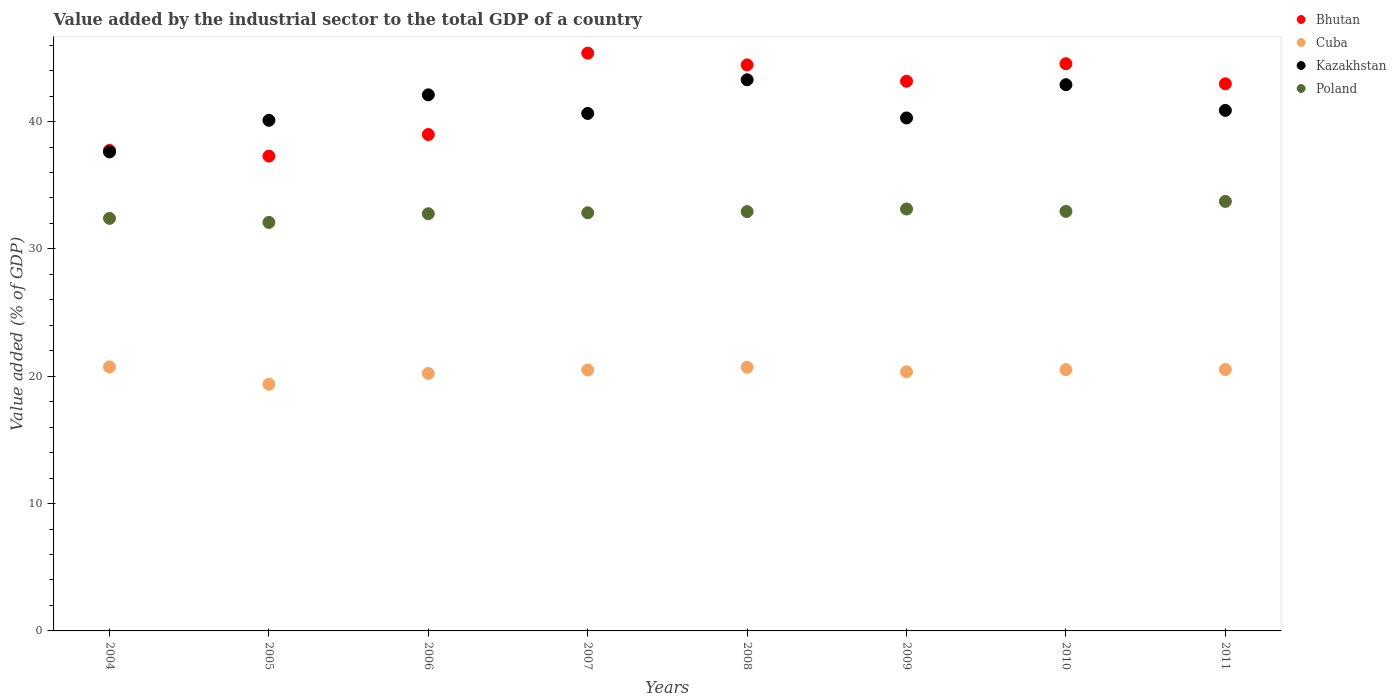What is the value added by the industrial sector to the total GDP in Cuba in 2006?
Make the answer very short. 20.22. Across all years, what is the maximum value added by the industrial sector to the total GDP in Bhutan?
Your answer should be compact. 45.38. Across all years, what is the minimum value added by the industrial sector to the total GDP in Kazakhstan?
Your response must be concise. 37.62. In which year was the value added by the industrial sector to the total GDP in Poland maximum?
Provide a short and direct response. 2011. In which year was the value added by the industrial sector to the total GDP in Cuba minimum?
Keep it short and to the point. 2005. What is the total value added by the industrial sector to the total GDP in Bhutan in the graph?
Ensure brevity in your answer.  334.52. What is the difference between the value added by the industrial sector to the total GDP in Cuba in 2006 and that in 2008?
Your answer should be compact. -0.49. What is the difference between the value added by the industrial sector to the total GDP in Cuba in 2005 and the value added by the industrial sector to the total GDP in Bhutan in 2009?
Make the answer very short. -23.8. What is the average value added by the industrial sector to the total GDP in Cuba per year?
Your response must be concise. 20.37. In the year 2010, what is the difference between the value added by the industrial sector to the total GDP in Poland and value added by the industrial sector to the total GDP in Bhutan?
Ensure brevity in your answer.  -11.6. In how many years, is the value added by the industrial sector to the total GDP in Cuba greater than 10 %?
Your response must be concise. 8. What is the ratio of the value added by the industrial sector to the total GDP in Bhutan in 2004 to that in 2007?
Your response must be concise. 0.83. Is the value added by the industrial sector to the total GDP in Poland in 2007 less than that in 2009?
Provide a succinct answer. Yes. Is the difference between the value added by the industrial sector to the total GDP in Poland in 2004 and 2007 greater than the difference between the value added by the industrial sector to the total GDP in Bhutan in 2004 and 2007?
Your response must be concise. Yes. What is the difference between the highest and the second highest value added by the industrial sector to the total GDP in Cuba?
Provide a short and direct response. 0.03. What is the difference between the highest and the lowest value added by the industrial sector to the total GDP in Bhutan?
Ensure brevity in your answer.  8.09. In how many years, is the value added by the industrial sector to the total GDP in Cuba greater than the average value added by the industrial sector to the total GDP in Cuba taken over all years?
Give a very brief answer. 5. Is the value added by the industrial sector to the total GDP in Bhutan strictly greater than the value added by the industrial sector to the total GDP in Poland over the years?
Give a very brief answer. Yes. Is the value added by the industrial sector to the total GDP in Bhutan strictly less than the value added by the industrial sector to the total GDP in Cuba over the years?
Give a very brief answer. No. Does the graph contain grids?
Offer a very short reply. No. How are the legend labels stacked?
Keep it short and to the point. Vertical. What is the title of the graph?
Give a very brief answer. Value added by the industrial sector to the total GDP of a country. Does "New Zealand" appear as one of the legend labels in the graph?
Provide a short and direct response. No. What is the label or title of the Y-axis?
Your response must be concise. Value added (% of GDP). What is the Value added (% of GDP) in Bhutan in 2004?
Make the answer very short. 37.74. What is the Value added (% of GDP) of Cuba in 2004?
Ensure brevity in your answer.  20.74. What is the Value added (% of GDP) in Kazakhstan in 2004?
Make the answer very short. 37.62. What is the Value added (% of GDP) of Poland in 2004?
Your answer should be very brief. 32.4. What is the Value added (% of GDP) of Bhutan in 2005?
Provide a short and direct response. 37.29. What is the Value added (% of GDP) of Cuba in 2005?
Provide a succinct answer. 19.37. What is the Value added (% of GDP) of Kazakhstan in 2005?
Make the answer very short. 40.1. What is the Value added (% of GDP) of Poland in 2005?
Keep it short and to the point. 32.08. What is the Value added (% of GDP) in Bhutan in 2006?
Keep it short and to the point. 38.99. What is the Value added (% of GDP) in Cuba in 2006?
Your answer should be compact. 20.22. What is the Value added (% of GDP) in Kazakhstan in 2006?
Make the answer very short. 42.1. What is the Value added (% of GDP) in Poland in 2006?
Make the answer very short. 32.76. What is the Value added (% of GDP) of Bhutan in 2007?
Make the answer very short. 45.38. What is the Value added (% of GDP) of Cuba in 2007?
Ensure brevity in your answer.  20.49. What is the Value added (% of GDP) of Kazakhstan in 2007?
Your response must be concise. 40.64. What is the Value added (% of GDP) of Poland in 2007?
Your answer should be compact. 32.84. What is the Value added (% of GDP) in Bhutan in 2008?
Keep it short and to the point. 44.45. What is the Value added (% of GDP) of Cuba in 2008?
Provide a short and direct response. 20.71. What is the Value added (% of GDP) in Kazakhstan in 2008?
Ensure brevity in your answer.  43.28. What is the Value added (% of GDP) of Poland in 2008?
Make the answer very short. 32.93. What is the Value added (% of GDP) of Bhutan in 2009?
Make the answer very short. 43.17. What is the Value added (% of GDP) in Cuba in 2009?
Offer a very short reply. 20.35. What is the Value added (% of GDP) in Kazakhstan in 2009?
Your response must be concise. 40.28. What is the Value added (% of GDP) in Poland in 2009?
Make the answer very short. 33.13. What is the Value added (% of GDP) of Bhutan in 2010?
Ensure brevity in your answer.  44.55. What is the Value added (% of GDP) of Cuba in 2010?
Provide a short and direct response. 20.52. What is the Value added (% of GDP) in Kazakhstan in 2010?
Offer a terse response. 42.9. What is the Value added (% of GDP) in Poland in 2010?
Your answer should be compact. 32.95. What is the Value added (% of GDP) of Bhutan in 2011?
Provide a short and direct response. 42.97. What is the Value added (% of GDP) of Cuba in 2011?
Provide a succinct answer. 20.53. What is the Value added (% of GDP) of Kazakhstan in 2011?
Your answer should be compact. 40.88. What is the Value added (% of GDP) of Poland in 2011?
Offer a terse response. 33.73. Across all years, what is the maximum Value added (% of GDP) in Bhutan?
Make the answer very short. 45.38. Across all years, what is the maximum Value added (% of GDP) of Cuba?
Offer a terse response. 20.74. Across all years, what is the maximum Value added (% of GDP) of Kazakhstan?
Offer a terse response. 43.28. Across all years, what is the maximum Value added (% of GDP) in Poland?
Ensure brevity in your answer.  33.73. Across all years, what is the minimum Value added (% of GDP) in Bhutan?
Give a very brief answer. 37.29. Across all years, what is the minimum Value added (% of GDP) in Cuba?
Provide a succinct answer. 19.37. Across all years, what is the minimum Value added (% of GDP) of Kazakhstan?
Provide a short and direct response. 37.62. Across all years, what is the minimum Value added (% of GDP) of Poland?
Your answer should be very brief. 32.08. What is the total Value added (% of GDP) in Bhutan in the graph?
Ensure brevity in your answer.  334.52. What is the total Value added (% of GDP) in Cuba in the graph?
Offer a very short reply. 162.92. What is the total Value added (% of GDP) in Kazakhstan in the graph?
Your response must be concise. 327.8. What is the total Value added (% of GDP) in Poland in the graph?
Give a very brief answer. 262.82. What is the difference between the Value added (% of GDP) of Bhutan in 2004 and that in 2005?
Your answer should be compact. 0.45. What is the difference between the Value added (% of GDP) in Cuba in 2004 and that in 2005?
Make the answer very short. 1.36. What is the difference between the Value added (% of GDP) of Kazakhstan in 2004 and that in 2005?
Keep it short and to the point. -2.48. What is the difference between the Value added (% of GDP) in Poland in 2004 and that in 2005?
Keep it short and to the point. 0.32. What is the difference between the Value added (% of GDP) of Bhutan in 2004 and that in 2006?
Your answer should be compact. -1.24. What is the difference between the Value added (% of GDP) in Cuba in 2004 and that in 2006?
Provide a succinct answer. 0.51. What is the difference between the Value added (% of GDP) of Kazakhstan in 2004 and that in 2006?
Make the answer very short. -4.49. What is the difference between the Value added (% of GDP) in Poland in 2004 and that in 2006?
Your answer should be compact. -0.36. What is the difference between the Value added (% of GDP) of Bhutan in 2004 and that in 2007?
Offer a very short reply. -7.63. What is the difference between the Value added (% of GDP) of Cuba in 2004 and that in 2007?
Keep it short and to the point. 0.24. What is the difference between the Value added (% of GDP) in Kazakhstan in 2004 and that in 2007?
Provide a short and direct response. -3.02. What is the difference between the Value added (% of GDP) of Poland in 2004 and that in 2007?
Offer a terse response. -0.44. What is the difference between the Value added (% of GDP) of Bhutan in 2004 and that in 2008?
Provide a short and direct response. -6.71. What is the difference between the Value added (% of GDP) of Cuba in 2004 and that in 2008?
Your answer should be very brief. 0.03. What is the difference between the Value added (% of GDP) in Kazakhstan in 2004 and that in 2008?
Your answer should be compact. -5.67. What is the difference between the Value added (% of GDP) in Poland in 2004 and that in 2008?
Give a very brief answer. -0.53. What is the difference between the Value added (% of GDP) of Bhutan in 2004 and that in 2009?
Offer a terse response. -5.43. What is the difference between the Value added (% of GDP) of Cuba in 2004 and that in 2009?
Ensure brevity in your answer.  0.38. What is the difference between the Value added (% of GDP) in Kazakhstan in 2004 and that in 2009?
Your response must be concise. -2.67. What is the difference between the Value added (% of GDP) of Poland in 2004 and that in 2009?
Provide a short and direct response. -0.74. What is the difference between the Value added (% of GDP) in Bhutan in 2004 and that in 2010?
Keep it short and to the point. -6.8. What is the difference between the Value added (% of GDP) of Cuba in 2004 and that in 2010?
Offer a very short reply. 0.22. What is the difference between the Value added (% of GDP) in Kazakhstan in 2004 and that in 2010?
Offer a very short reply. -5.28. What is the difference between the Value added (% of GDP) in Poland in 2004 and that in 2010?
Offer a very short reply. -0.55. What is the difference between the Value added (% of GDP) in Bhutan in 2004 and that in 2011?
Offer a very short reply. -5.22. What is the difference between the Value added (% of GDP) in Cuba in 2004 and that in 2011?
Keep it short and to the point. 0.21. What is the difference between the Value added (% of GDP) in Kazakhstan in 2004 and that in 2011?
Make the answer very short. -3.26. What is the difference between the Value added (% of GDP) in Poland in 2004 and that in 2011?
Offer a terse response. -1.33. What is the difference between the Value added (% of GDP) in Bhutan in 2005 and that in 2006?
Offer a terse response. -1.7. What is the difference between the Value added (% of GDP) in Cuba in 2005 and that in 2006?
Ensure brevity in your answer.  -0.85. What is the difference between the Value added (% of GDP) of Kazakhstan in 2005 and that in 2006?
Ensure brevity in your answer.  -2. What is the difference between the Value added (% of GDP) of Poland in 2005 and that in 2006?
Offer a terse response. -0.68. What is the difference between the Value added (% of GDP) of Bhutan in 2005 and that in 2007?
Your response must be concise. -8.09. What is the difference between the Value added (% of GDP) of Cuba in 2005 and that in 2007?
Your response must be concise. -1.12. What is the difference between the Value added (% of GDP) of Kazakhstan in 2005 and that in 2007?
Your response must be concise. -0.54. What is the difference between the Value added (% of GDP) in Poland in 2005 and that in 2007?
Ensure brevity in your answer.  -0.76. What is the difference between the Value added (% of GDP) of Bhutan in 2005 and that in 2008?
Give a very brief answer. -7.16. What is the difference between the Value added (% of GDP) of Cuba in 2005 and that in 2008?
Give a very brief answer. -1.34. What is the difference between the Value added (% of GDP) of Kazakhstan in 2005 and that in 2008?
Provide a succinct answer. -3.18. What is the difference between the Value added (% of GDP) in Poland in 2005 and that in 2008?
Offer a terse response. -0.85. What is the difference between the Value added (% of GDP) of Bhutan in 2005 and that in 2009?
Make the answer very short. -5.88. What is the difference between the Value added (% of GDP) in Cuba in 2005 and that in 2009?
Keep it short and to the point. -0.98. What is the difference between the Value added (% of GDP) of Kazakhstan in 2005 and that in 2009?
Give a very brief answer. -0.18. What is the difference between the Value added (% of GDP) of Poland in 2005 and that in 2009?
Give a very brief answer. -1.05. What is the difference between the Value added (% of GDP) of Bhutan in 2005 and that in 2010?
Give a very brief answer. -7.26. What is the difference between the Value added (% of GDP) in Cuba in 2005 and that in 2010?
Ensure brevity in your answer.  -1.15. What is the difference between the Value added (% of GDP) of Kazakhstan in 2005 and that in 2010?
Provide a succinct answer. -2.8. What is the difference between the Value added (% of GDP) in Poland in 2005 and that in 2010?
Keep it short and to the point. -0.87. What is the difference between the Value added (% of GDP) of Bhutan in 2005 and that in 2011?
Offer a terse response. -5.68. What is the difference between the Value added (% of GDP) of Cuba in 2005 and that in 2011?
Keep it short and to the point. -1.16. What is the difference between the Value added (% of GDP) in Kazakhstan in 2005 and that in 2011?
Provide a succinct answer. -0.78. What is the difference between the Value added (% of GDP) in Poland in 2005 and that in 2011?
Provide a short and direct response. -1.65. What is the difference between the Value added (% of GDP) in Bhutan in 2006 and that in 2007?
Provide a short and direct response. -6.39. What is the difference between the Value added (% of GDP) of Cuba in 2006 and that in 2007?
Your answer should be very brief. -0.27. What is the difference between the Value added (% of GDP) in Kazakhstan in 2006 and that in 2007?
Offer a terse response. 1.46. What is the difference between the Value added (% of GDP) in Poland in 2006 and that in 2007?
Make the answer very short. -0.07. What is the difference between the Value added (% of GDP) of Bhutan in 2006 and that in 2008?
Your answer should be very brief. -5.47. What is the difference between the Value added (% of GDP) in Cuba in 2006 and that in 2008?
Give a very brief answer. -0.49. What is the difference between the Value added (% of GDP) of Kazakhstan in 2006 and that in 2008?
Keep it short and to the point. -1.18. What is the difference between the Value added (% of GDP) in Poland in 2006 and that in 2008?
Your response must be concise. -0.16. What is the difference between the Value added (% of GDP) of Bhutan in 2006 and that in 2009?
Your answer should be very brief. -4.18. What is the difference between the Value added (% of GDP) in Cuba in 2006 and that in 2009?
Offer a very short reply. -0.13. What is the difference between the Value added (% of GDP) of Kazakhstan in 2006 and that in 2009?
Make the answer very short. 1.82. What is the difference between the Value added (% of GDP) of Poland in 2006 and that in 2009?
Provide a short and direct response. -0.37. What is the difference between the Value added (% of GDP) of Bhutan in 2006 and that in 2010?
Ensure brevity in your answer.  -5.56. What is the difference between the Value added (% of GDP) in Cuba in 2006 and that in 2010?
Offer a very short reply. -0.3. What is the difference between the Value added (% of GDP) in Kazakhstan in 2006 and that in 2010?
Your answer should be compact. -0.8. What is the difference between the Value added (% of GDP) in Poland in 2006 and that in 2010?
Provide a succinct answer. -0.18. What is the difference between the Value added (% of GDP) in Bhutan in 2006 and that in 2011?
Make the answer very short. -3.98. What is the difference between the Value added (% of GDP) of Cuba in 2006 and that in 2011?
Provide a short and direct response. -0.3. What is the difference between the Value added (% of GDP) of Kazakhstan in 2006 and that in 2011?
Provide a short and direct response. 1.22. What is the difference between the Value added (% of GDP) in Poland in 2006 and that in 2011?
Your response must be concise. -0.97. What is the difference between the Value added (% of GDP) of Bhutan in 2007 and that in 2008?
Make the answer very short. 0.92. What is the difference between the Value added (% of GDP) in Cuba in 2007 and that in 2008?
Provide a short and direct response. -0.21. What is the difference between the Value added (% of GDP) of Kazakhstan in 2007 and that in 2008?
Your response must be concise. -2.65. What is the difference between the Value added (% of GDP) in Poland in 2007 and that in 2008?
Ensure brevity in your answer.  -0.09. What is the difference between the Value added (% of GDP) in Bhutan in 2007 and that in 2009?
Offer a terse response. 2.21. What is the difference between the Value added (% of GDP) of Cuba in 2007 and that in 2009?
Ensure brevity in your answer.  0.14. What is the difference between the Value added (% of GDP) in Kazakhstan in 2007 and that in 2009?
Keep it short and to the point. 0.35. What is the difference between the Value added (% of GDP) in Poland in 2007 and that in 2009?
Give a very brief answer. -0.3. What is the difference between the Value added (% of GDP) in Bhutan in 2007 and that in 2010?
Make the answer very short. 0.83. What is the difference between the Value added (% of GDP) in Cuba in 2007 and that in 2010?
Offer a very short reply. -0.02. What is the difference between the Value added (% of GDP) in Kazakhstan in 2007 and that in 2010?
Make the answer very short. -2.26. What is the difference between the Value added (% of GDP) of Poland in 2007 and that in 2010?
Your response must be concise. -0.11. What is the difference between the Value added (% of GDP) in Bhutan in 2007 and that in 2011?
Offer a very short reply. 2.41. What is the difference between the Value added (% of GDP) in Cuba in 2007 and that in 2011?
Offer a very short reply. -0.03. What is the difference between the Value added (% of GDP) of Kazakhstan in 2007 and that in 2011?
Offer a very short reply. -0.24. What is the difference between the Value added (% of GDP) of Poland in 2007 and that in 2011?
Your answer should be compact. -0.89. What is the difference between the Value added (% of GDP) in Bhutan in 2008 and that in 2009?
Offer a very short reply. 1.28. What is the difference between the Value added (% of GDP) of Cuba in 2008 and that in 2009?
Your answer should be compact. 0.35. What is the difference between the Value added (% of GDP) of Kazakhstan in 2008 and that in 2009?
Your answer should be compact. 3. What is the difference between the Value added (% of GDP) in Poland in 2008 and that in 2009?
Give a very brief answer. -0.21. What is the difference between the Value added (% of GDP) in Bhutan in 2008 and that in 2010?
Offer a terse response. -0.09. What is the difference between the Value added (% of GDP) in Cuba in 2008 and that in 2010?
Your response must be concise. 0.19. What is the difference between the Value added (% of GDP) of Kazakhstan in 2008 and that in 2010?
Offer a terse response. 0.39. What is the difference between the Value added (% of GDP) of Poland in 2008 and that in 2010?
Your response must be concise. -0.02. What is the difference between the Value added (% of GDP) of Bhutan in 2008 and that in 2011?
Your answer should be compact. 1.48. What is the difference between the Value added (% of GDP) in Cuba in 2008 and that in 2011?
Make the answer very short. 0.18. What is the difference between the Value added (% of GDP) of Kazakhstan in 2008 and that in 2011?
Make the answer very short. 2.4. What is the difference between the Value added (% of GDP) in Poland in 2008 and that in 2011?
Give a very brief answer. -0.8. What is the difference between the Value added (% of GDP) of Bhutan in 2009 and that in 2010?
Ensure brevity in your answer.  -1.38. What is the difference between the Value added (% of GDP) of Cuba in 2009 and that in 2010?
Ensure brevity in your answer.  -0.16. What is the difference between the Value added (% of GDP) of Kazakhstan in 2009 and that in 2010?
Offer a terse response. -2.61. What is the difference between the Value added (% of GDP) in Poland in 2009 and that in 2010?
Provide a succinct answer. 0.19. What is the difference between the Value added (% of GDP) in Bhutan in 2009 and that in 2011?
Make the answer very short. 0.2. What is the difference between the Value added (% of GDP) in Cuba in 2009 and that in 2011?
Provide a short and direct response. -0.17. What is the difference between the Value added (% of GDP) in Kazakhstan in 2009 and that in 2011?
Keep it short and to the point. -0.59. What is the difference between the Value added (% of GDP) in Poland in 2009 and that in 2011?
Your response must be concise. -0.6. What is the difference between the Value added (% of GDP) of Bhutan in 2010 and that in 2011?
Make the answer very short. 1.58. What is the difference between the Value added (% of GDP) in Cuba in 2010 and that in 2011?
Make the answer very short. -0.01. What is the difference between the Value added (% of GDP) of Kazakhstan in 2010 and that in 2011?
Your answer should be very brief. 2.02. What is the difference between the Value added (% of GDP) in Poland in 2010 and that in 2011?
Offer a terse response. -0.78. What is the difference between the Value added (% of GDP) of Bhutan in 2004 and the Value added (% of GDP) of Cuba in 2005?
Provide a succinct answer. 18.37. What is the difference between the Value added (% of GDP) in Bhutan in 2004 and the Value added (% of GDP) in Kazakhstan in 2005?
Keep it short and to the point. -2.36. What is the difference between the Value added (% of GDP) in Bhutan in 2004 and the Value added (% of GDP) in Poland in 2005?
Your response must be concise. 5.66. What is the difference between the Value added (% of GDP) in Cuba in 2004 and the Value added (% of GDP) in Kazakhstan in 2005?
Your answer should be compact. -19.36. What is the difference between the Value added (% of GDP) in Cuba in 2004 and the Value added (% of GDP) in Poland in 2005?
Your response must be concise. -11.35. What is the difference between the Value added (% of GDP) in Kazakhstan in 2004 and the Value added (% of GDP) in Poland in 2005?
Ensure brevity in your answer.  5.53. What is the difference between the Value added (% of GDP) in Bhutan in 2004 and the Value added (% of GDP) in Cuba in 2006?
Give a very brief answer. 17.52. What is the difference between the Value added (% of GDP) in Bhutan in 2004 and the Value added (% of GDP) in Kazakhstan in 2006?
Provide a short and direct response. -4.36. What is the difference between the Value added (% of GDP) in Bhutan in 2004 and the Value added (% of GDP) in Poland in 2006?
Provide a short and direct response. 4.98. What is the difference between the Value added (% of GDP) in Cuba in 2004 and the Value added (% of GDP) in Kazakhstan in 2006?
Give a very brief answer. -21.37. What is the difference between the Value added (% of GDP) of Cuba in 2004 and the Value added (% of GDP) of Poland in 2006?
Provide a short and direct response. -12.03. What is the difference between the Value added (% of GDP) in Kazakhstan in 2004 and the Value added (% of GDP) in Poland in 2006?
Your answer should be compact. 4.85. What is the difference between the Value added (% of GDP) of Bhutan in 2004 and the Value added (% of GDP) of Cuba in 2007?
Offer a terse response. 17.25. What is the difference between the Value added (% of GDP) of Bhutan in 2004 and the Value added (% of GDP) of Kazakhstan in 2007?
Your answer should be compact. -2.9. What is the difference between the Value added (% of GDP) in Bhutan in 2004 and the Value added (% of GDP) in Poland in 2007?
Your answer should be very brief. 4.9. What is the difference between the Value added (% of GDP) in Cuba in 2004 and the Value added (% of GDP) in Kazakhstan in 2007?
Provide a short and direct response. -19.9. What is the difference between the Value added (% of GDP) in Cuba in 2004 and the Value added (% of GDP) in Poland in 2007?
Offer a very short reply. -12.1. What is the difference between the Value added (% of GDP) of Kazakhstan in 2004 and the Value added (% of GDP) of Poland in 2007?
Ensure brevity in your answer.  4.78. What is the difference between the Value added (% of GDP) in Bhutan in 2004 and the Value added (% of GDP) in Cuba in 2008?
Your answer should be very brief. 17.04. What is the difference between the Value added (% of GDP) of Bhutan in 2004 and the Value added (% of GDP) of Kazakhstan in 2008?
Offer a very short reply. -5.54. What is the difference between the Value added (% of GDP) in Bhutan in 2004 and the Value added (% of GDP) in Poland in 2008?
Offer a terse response. 4.81. What is the difference between the Value added (% of GDP) in Cuba in 2004 and the Value added (% of GDP) in Kazakhstan in 2008?
Make the answer very short. -22.55. What is the difference between the Value added (% of GDP) of Cuba in 2004 and the Value added (% of GDP) of Poland in 2008?
Offer a terse response. -12.19. What is the difference between the Value added (% of GDP) of Kazakhstan in 2004 and the Value added (% of GDP) of Poland in 2008?
Keep it short and to the point. 4.69. What is the difference between the Value added (% of GDP) in Bhutan in 2004 and the Value added (% of GDP) in Cuba in 2009?
Make the answer very short. 17.39. What is the difference between the Value added (% of GDP) of Bhutan in 2004 and the Value added (% of GDP) of Kazakhstan in 2009?
Keep it short and to the point. -2.54. What is the difference between the Value added (% of GDP) in Bhutan in 2004 and the Value added (% of GDP) in Poland in 2009?
Give a very brief answer. 4.61. What is the difference between the Value added (% of GDP) in Cuba in 2004 and the Value added (% of GDP) in Kazakhstan in 2009?
Ensure brevity in your answer.  -19.55. What is the difference between the Value added (% of GDP) in Cuba in 2004 and the Value added (% of GDP) in Poland in 2009?
Make the answer very short. -12.4. What is the difference between the Value added (% of GDP) in Kazakhstan in 2004 and the Value added (% of GDP) in Poland in 2009?
Your response must be concise. 4.48. What is the difference between the Value added (% of GDP) in Bhutan in 2004 and the Value added (% of GDP) in Cuba in 2010?
Make the answer very short. 17.23. What is the difference between the Value added (% of GDP) in Bhutan in 2004 and the Value added (% of GDP) in Kazakhstan in 2010?
Offer a terse response. -5.15. What is the difference between the Value added (% of GDP) in Bhutan in 2004 and the Value added (% of GDP) in Poland in 2010?
Your answer should be very brief. 4.8. What is the difference between the Value added (% of GDP) in Cuba in 2004 and the Value added (% of GDP) in Kazakhstan in 2010?
Give a very brief answer. -22.16. What is the difference between the Value added (% of GDP) of Cuba in 2004 and the Value added (% of GDP) of Poland in 2010?
Offer a terse response. -12.21. What is the difference between the Value added (% of GDP) of Kazakhstan in 2004 and the Value added (% of GDP) of Poland in 2010?
Offer a terse response. 4.67. What is the difference between the Value added (% of GDP) in Bhutan in 2004 and the Value added (% of GDP) in Cuba in 2011?
Give a very brief answer. 17.22. What is the difference between the Value added (% of GDP) of Bhutan in 2004 and the Value added (% of GDP) of Kazakhstan in 2011?
Make the answer very short. -3.14. What is the difference between the Value added (% of GDP) in Bhutan in 2004 and the Value added (% of GDP) in Poland in 2011?
Keep it short and to the point. 4.01. What is the difference between the Value added (% of GDP) of Cuba in 2004 and the Value added (% of GDP) of Kazakhstan in 2011?
Make the answer very short. -20.14. What is the difference between the Value added (% of GDP) in Cuba in 2004 and the Value added (% of GDP) in Poland in 2011?
Offer a terse response. -13. What is the difference between the Value added (% of GDP) in Kazakhstan in 2004 and the Value added (% of GDP) in Poland in 2011?
Ensure brevity in your answer.  3.88. What is the difference between the Value added (% of GDP) of Bhutan in 2005 and the Value added (% of GDP) of Cuba in 2006?
Provide a short and direct response. 17.07. What is the difference between the Value added (% of GDP) of Bhutan in 2005 and the Value added (% of GDP) of Kazakhstan in 2006?
Keep it short and to the point. -4.81. What is the difference between the Value added (% of GDP) in Bhutan in 2005 and the Value added (% of GDP) in Poland in 2006?
Your response must be concise. 4.53. What is the difference between the Value added (% of GDP) of Cuba in 2005 and the Value added (% of GDP) of Kazakhstan in 2006?
Your answer should be compact. -22.73. What is the difference between the Value added (% of GDP) of Cuba in 2005 and the Value added (% of GDP) of Poland in 2006?
Provide a succinct answer. -13.39. What is the difference between the Value added (% of GDP) in Kazakhstan in 2005 and the Value added (% of GDP) in Poland in 2006?
Your answer should be very brief. 7.34. What is the difference between the Value added (% of GDP) in Bhutan in 2005 and the Value added (% of GDP) in Cuba in 2007?
Make the answer very short. 16.8. What is the difference between the Value added (% of GDP) of Bhutan in 2005 and the Value added (% of GDP) of Kazakhstan in 2007?
Ensure brevity in your answer.  -3.35. What is the difference between the Value added (% of GDP) of Bhutan in 2005 and the Value added (% of GDP) of Poland in 2007?
Provide a short and direct response. 4.45. What is the difference between the Value added (% of GDP) in Cuba in 2005 and the Value added (% of GDP) in Kazakhstan in 2007?
Your answer should be very brief. -21.27. What is the difference between the Value added (% of GDP) in Cuba in 2005 and the Value added (% of GDP) in Poland in 2007?
Your answer should be compact. -13.47. What is the difference between the Value added (% of GDP) in Kazakhstan in 2005 and the Value added (% of GDP) in Poland in 2007?
Your answer should be compact. 7.26. What is the difference between the Value added (% of GDP) in Bhutan in 2005 and the Value added (% of GDP) in Cuba in 2008?
Offer a terse response. 16.58. What is the difference between the Value added (% of GDP) in Bhutan in 2005 and the Value added (% of GDP) in Kazakhstan in 2008?
Your answer should be compact. -6. What is the difference between the Value added (% of GDP) in Bhutan in 2005 and the Value added (% of GDP) in Poland in 2008?
Offer a very short reply. 4.36. What is the difference between the Value added (% of GDP) in Cuba in 2005 and the Value added (% of GDP) in Kazakhstan in 2008?
Your answer should be very brief. -23.91. What is the difference between the Value added (% of GDP) of Cuba in 2005 and the Value added (% of GDP) of Poland in 2008?
Keep it short and to the point. -13.56. What is the difference between the Value added (% of GDP) in Kazakhstan in 2005 and the Value added (% of GDP) in Poland in 2008?
Offer a terse response. 7.17. What is the difference between the Value added (% of GDP) of Bhutan in 2005 and the Value added (% of GDP) of Cuba in 2009?
Your answer should be very brief. 16.94. What is the difference between the Value added (% of GDP) in Bhutan in 2005 and the Value added (% of GDP) in Kazakhstan in 2009?
Provide a succinct answer. -3. What is the difference between the Value added (% of GDP) in Bhutan in 2005 and the Value added (% of GDP) in Poland in 2009?
Give a very brief answer. 4.16. What is the difference between the Value added (% of GDP) of Cuba in 2005 and the Value added (% of GDP) of Kazakhstan in 2009?
Provide a short and direct response. -20.91. What is the difference between the Value added (% of GDP) in Cuba in 2005 and the Value added (% of GDP) in Poland in 2009?
Make the answer very short. -13.76. What is the difference between the Value added (% of GDP) in Kazakhstan in 2005 and the Value added (% of GDP) in Poland in 2009?
Provide a short and direct response. 6.97. What is the difference between the Value added (% of GDP) of Bhutan in 2005 and the Value added (% of GDP) of Cuba in 2010?
Your answer should be compact. 16.77. What is the difference between the Value added (% of GDP) of Bhutan in 2005 and the Value added (% of GDP) of Kazakhstan in 2010?
Offer a terse response. -5.61. What is the difference between the Value added (% of GDP) of Bhutan in 2005 and the Value added (% of GDP) of Poland in 2010?
Keep it short and to the point. 4.34. What is the difference between the Value added (% of GDP) of Cuba in 2005 and the Value added (% of GDP) of Kazakhstan in 2010?
Your answer should be compact. -23.53. What is the difference between the Value added (% of GDP) of Cuba in 2005 and the Value added (% of GDP) of Poland in 2010?
Keep it short and to the point. -13.58. What is the difference between the Value added (% of GDP) in Kazakhstan in 2005 and the Value added (% of GDP) in Poland in 2010?
Give a very brief answer. 7.15. What is the difference between the Value added (% of GDP) in Bhutan in 2005 and the Value added (% of GDP) in Cuba in 2011?
Your answer should be very brief. 16.76. What is the difference between the Value added (% of GDP) of Bhutan in 2005 and the Value added (% of GDP) of Kazakhstan in 2011?
Ensure brevity in your answer.  -3.59. What is the difference between the Value added (% of GDP) of Bhutan in 2005 and the Value added (% of GDP) of Poland in 2011?
Provide a short and direct response. 3.56. What is the difference between the Value added (% of GDP) of Cuba in 2005 and the Value added (% of GDP) of Kazakhstan in 2011?
Give a very brief answer. -21.51. What is the difference between the Value added (% of GDP) of Cuba in 2005 and the Value added (% of GDP) of Poland in 2011?
Offer a very short reply. -14.36. What is the difference between the Value added (% of GDP) in Kazakhstan in 2005 and the Value added (% of GDP) in Poland in 2011?
Keep it short and to the point. 6.37. What is the difference between the Value added (% of GDP) in Bhutan in 2006 and the Value added (% of GDP) in Cuba in 2007?
Your response must be concise. 18.49. What is the difference between the Value added (% of GDP) in Bhutan in 2006 and the Value added (% of GDP) in Kazakhstan in 2007?
Your answer should be compact. -1.65. What is the difference between the Value added (% of GDP) of Bhutan in 2006 and the Value added (% of GDP) of Poland in 2007?
Provide a succinct answer. 6.15. What is the difference between the Value added (% of GDP) of Cuba in 2006 and the Value added (% of GDP) of Kazakhstan in 2007?
Offer a very short reply. -20.42. What is the difference between the Value added (% of GDP) of Cuba in 2006 and the Value added (% of GDP) of Poland in 2007?
Your answer should be compact. -12.62. What is the difference between the Value added (% of GDP) of Kazakhstan in 2006 and the Value added (% of GDP) of Poland in 2007?
Give a very brief answer. 9.26. What is the difference between the Value added (% of GDP) in Bhutan in 2006 and the Value added (% of GDP) in Cuba in 2008?
Offer a terse response. 18.28. What is the difference between the Value added (% of GDP) in Bhutan in 2006 and the Value added (% of GDP) in Kazakhstan in 2008?
Provide a succinct answer. -4.3. What is the difference between the Value added (% of GDP) in Bhutan in 2006 and the Value added (% of GDP) in Poland in 2008?
Keep it short and to the point. 6.06. What is the difference between the Value added (% of GDP) in Cuba in 2006 and the Value added (% of GDP) in Kazakhstan in 2008?
Provide a short and direct response. -23.06. What is the difference between the Value added (% of GDP) in Cuba in 2006 and the Value added (% of GDP) in Poland in 2008?
Your answer should be very brief. -12.71. What is the difference between the Value added (% of GDP) in Kazakhstan in 2006 and the Value added (% of GDP) in Poland in 2008?
Your response must be concise. 9.17. What is the difference between the Value added (% of GDP) of Bhutan in 2006 and the Value added (% of GDP) of Cuba in 2009?
Make the answer very short. 18.63. What is the difference between the Value added (% of GDP) in Bhutan in 2006 and the Value added (% of GDP) in Kazakhstan in 2009?
Make the answer very short. -1.3. What is the difference between the Value added (% of GDP) of Bhutan in 2006 and the Value added (% of GDP) of Poland in 2009?
Ensure brevity in your answer.  5.85. What is the difference between the Value added (% of GDP) in Cuba in 2006 and the Value added (% of GDP) in Kazakhstan in 2009?
Ensure brevity in your answer.  -20.06. What is the difference between the Value added (% of GDP) of Cuba in 2006 and the Value added (% of GDP) of Poland in 2009?
Offer a terse response. -12.91. What is the difference between the Value added (% of GDP) of Kazakhstan in 2006 and the Value added (% of GDP) of Poland in 2009?
Make the answer very short. 8.97. What is the difference between the Value added (% of GDP) of Bhutan in 2006 and the Value added (% of GDP) of Cuba in 2010?
Ensure brevity in your answer.  18.47. What is the difference between the Value added (% of GDP) of Bhutan in 2006 and the Value added (% of GDP) of Kazakhstan in 2010?
Offer a terse response. -3.91. What is the difference between the Value added (% of GDP) of Bhutan in 2006 and the Value added (% of GDP) of Poland in 2010?
Give a very brief answer. 6.04. What is the difference between the Value added (% of GDP) in Cuba in 2006 and the Value added (% of GDP) in Kazakhstan in 2010?
Your response must be concise. -22.68. What is the difference between the Value added (% of GDP) in Cuba in 2006 and the Value added (% of GDP) in Poland in 2010?
Provide a short and direct response. -12.73. What is the difference between the Value added (% of GDP) of Kazakhstan in 2006 and the Value added (% of GDP) of Poland in 2010?
Keep it short and to the point. 9.15. What is the difference between the Value added (% of GDP) in Bhutan in 2006 and the Value added (% of GDP) in Cuba in 2011?
Your answer should be compact. 18.46. What is the difference between the Value added (% of GDP) of Bhutan in 2006 and the Value added (% of GDP) of Kazakhstan in 2011?
Your answer should be very brief. -1.89. What is the difference between the Value added (% of GDP) of Bhutan in 2006 and the Value added (% of GDP) of Poland in 2011?
Make the answer very short. 5.25. What is the difference between the Value added (% of GDP) of Cuba in 2006 and the Value added (% of GDP) of Kazakhstan in 2011?
Ensure brevity in your answer.  -20.66. What is the difference between the Value added (% of GDP) in Cuba in 2006 and the Value added (% of GDP) in Poland in 2011?
Provide a short and direct response. -13.51. What is the difference between the Value added (% of GDP) in Kazakhstan in 2006 and the Value added (% of GDP) in Poland in 2011?
Make the answer very short. 8.37. What is the difference between the Value added (% of GDP) of Bhutan in 2007 and the Value added (% of GDP) of Cuba in 2008?
Offer a terse response. 24.67. What is the difference between the Value added (% of GDP) of Bhutan in 2007 and the Value added (% of GDP) of Kazakhstan in 2008?
Keep it short and to the point. 2.09. What is the difference between the Value added (% of GDP) in Bhutan in 2007 and the Value added (% of GDP) in Poland in 2008?
Ensure brevity in your answer.  12.45. What is the difference between the Value added (% of GDP) of Cuba in 2007 and the Value added (% of GDP) of Kazakhstan in 2008?
Provide a short and direct response. -22.79. What is the difference between the Value added (% of GDP) of Cuba in 2007 and the Value added (% of GDP) of Poland in 2008?
Make the answer very short. -12.43. What is the difference between the Value added (% of GDP) in Kazakhstan in 2007 and the Value added (% of GDP) in Poland in 2008?
Provide a short and direct response. 7.71. What is the difference between the Value added (% of GDP) of Bhutan in 2007 and the Value added (% of GDP) of Cuba in 2009?
Keep it short and to the point. 25.02. What is the difference between the Value added (% of GDP) in Bhutan in 2007 and the Value added (% of GDP) in Kazakhstan in 2009?
Keep it short and to the point. 5.09. What is the difference between the Value added (% of GDP) of Bhutan in 2007 and the Value added (% of GDP) of Poland in 2009?
Keep it short and to the point. 12.24. What is the difference between the Value added (% of GDP) of Cuba in 2007 and the Value added (% of GDP) of Kazakhstan in 2009?
Keep it short and to the point. -19.79. What is the difference between the Value added (% of GDP) in Cuba in 2007 and the Value added (% of GDP) in Poland in 2009?
Offer a very short reply. -12.64. What is the difference between the Value added (% of GDP) in Kazakhstan in 2007 and the Value added (% of GDP) in Poland in 2009?
Give a very brief answer. 7.51. What is the difference between the Value added (% of GDP) in Bhutan in 2007 and the Value added (% of GDP) in Cuba in 2010?
Offer a very short reply. 24.86. What is the difference between the Value added (% of GDP) of Bhutan in 2007 and the Value added (% of GDP) of Kazakhstan in 2010?
Your response must be concise. 2.48. What is the difference between the Value added (% of GDP) in Bhutan in 2007 and the Value added (% of GDP) in Poland in 2010?
Give a very brief answer. 12.43. What is the difference between the Value added (% of GDP) in Cuba in 2007 and the Value added (% of GDP) in Kazakhstan in 2010?
Provide a short and direct response. -22.4. What is the difference between the Value added (% of GDP) of Cuba in 2007 and the Value added (% of GDP) of Poland in 2010?
Give a very brief answer. -12.45. What is the difference between the Value added (% of GDP) in Kazakhstan in 2007 and the Value added (% of GDP) in Poland in 2010?
Provide a succinct answer. 7.69. What is the difference between the Value added (% of GDP) in Bhutan in 2007 and the Value added (% of GDP) in Cuba in 2011?
Offer a very short reply. 24.85. What is the difference between the Value added (% of GDP) in Bhutan in 2007 and the Value added (% of GDP) in Kazakhstan in 2011?
Your answer should be very brief. 4.5. What is the difference between the Value added (% of GDP) of Bhutan in 2007 and the Value added (% of GDP) of Poland in 2011?
Ensure brevity in your answer.  11.64. What is the difference between the Value added (% of GDP) of Cuba in 2007 and the Value added (% of GDP) of Kazakhstan in 2011?
Your answer should be very brief. -20.39. What is the difference between the Value added (% of GDP) of Cuba in 2007 and the Value added (% of GDP) of Poland in 2011?
Ensure brevity in your answer.  -13.24. What is the difference between the Value added (% of GDP) of Kazakhstan in 2007 and the Value added (% of GDP) of Poland in 2011?
Provide a succinct answer. 6.91. What is the difference between the Value added (% of GDP) in Bhutan in 2008 and the Value added (% of GDP) in Cuba in 2009?
Ensure brevity in your answer.  24.1. What is the difference between the Value added (% of GDP) of Bhutan in 2008 and the Value added (% of GDP) of Kazakhstan in 2009?
Your answer should be very brief. 4.17. What is the difference between the Value added (% of GDP) of Bhutan in 2008 and the Value added (% of GDP) of Poland in 2009?
Offer a very short reply. 11.32. What is the difference between the Value added (% of GDP) in Cuba in 2008 and the Value added (% of GDP) in Kazakhstan in 2009?
Your answer should be very brief. -19.58. What is the difference between the Value added (% of GDP) in Cuba in 2008 and the Value added (% of GDP) in Poland in 2009?
Offer a very short reply. -12.43. What is the difference between the Value added (% of GDP) of Kazakhstan in 2008 and the Value added (% of GDP) of Poland in 2009?
Offer a terse response. 10.15. What is the difference between the Value added (% of GDP) of Bhutan in 2008 and the Value added (% of GDP) of Cuba in 2010?
Your response must be concise. 23.93. What is the difference between the Value added (% of GDP) in Bhutan in 2008 and the Value added (% of GDP) in Kazakhstan in 2010?
Offer a very short reply. 1.56. What is the difference between the Value added (% of GDP) in Bhutan in 2008 and the Value added (% of GDP) in Poland in 2010?
Your response must be concise. 11.5. What is the difference between the Value added (% of GDP) of Cuba in 2008 and the Value added (% of GDP) of Kazakhstan in 2010?
Keep it short and to the point. -22.19. What is the difference between the Value added (% of GDP) in Cuba in 2008 and the Value added (% of GDP) in Poland in 2010?
Provide a succinct answer. -12.24. What is the difference between the Value added (% of GDP) in Kazakhstan in 2008 and the Value added (% of GDP) in Poland in 2010?
Keep it short and to the point. 10.34. What is the difference between the Value added (% of GDP) in Bhutan in 2008 and the Value added (% of GDP) in Cuba in 2011?
Make the answer very short. 23.93. What is the difference between the Value added (% of GDP) in Bhutan in 2008 and the Value added (% of GDP) in Kazakhstan in 2011?
Your answer should be very brief. 3.57. What is the difference between the Value added (% of GDP) of Bhutan in 2008 and the Value added (% of GDP) of Poland in 2011?
Your answer should be compact. 10.72. What is the difference between the Value added (% of GDP) in Cuba in 2008 and the Value added (% of GDP) in Kazakhstan in 2011?
Make the answer very short. -20.17. What is the difference between the Value added (% of GDP) of Cuba in 2008 and the Value added (% of GDP) of Poland in 2011?
Offer a very short reply. -13.02. What is the difference between the Value added (% of GDP) in Kazakhstan in 2008 and the Value added (% of GDP) in Poland in 2011?
Your response must be concise. 9.55. What is the difference between the Value added (% of GDP) of Bhutan in 2009 and the Value added (% of GDP) of Cuba in 2010?
Your answer should be compact. 22.65. What is the difference between the Value added (% of GDP) in Bhutan in 2009 and the Value added (% of GDP) in Kazakhstan in 2010?
Your response must be concise. 0.27. What is the difference between the Value added (% of GDP) in Bhutan in 2009 and the Value added (% of GDP) in Poland in 2010?
Offer a terse response. 10.22. What is the difference between the Value added (% of GDP) in Cuba in 2009 and the Value added (% of GDP) in Kazakhstan in 2010?
Offer a very short reply. -22.54. What is the difference between the Value added (% of GDP) in Cuba in 2009 and the Value added (% of GDP) in Poland in 2010?
Keep it short and to the point. -12.59. What is the difference between the Value added (% of GDP) in Kazakhstan in 2009 and the Value added (% of GDP) in Poland in 2010?
Keep it short and to the point. 7.34. What is the difference between the Value added (% of GDP) in Bhutan in 2009 and the Value added (% of GDP) in Cuba in 2011?
Give a very brief answer. 22.64. What is the difference between the Value added (% of GDP) in Bhutan in 2009 and the Value added (% of GDP) in Kazakhstan in 2011?
Offer a terse response. 2.29. What is the difference between the Value added (% of GDP) in Bhutan in 2009 and the Value added (% of GDP) in Poland in 2011?
Provide a short and direct response. 9.44. What is the difference between the Value added (% of GDP) of Cuba in 2009 and the Value added (% of GDP) of Kazakhstan in 2011?
Provide a succinct answer. -20.53. What is the difference between the Value added (% of GDP) in Cuba in 2009 and the Value added (% of GDP) in Poland in 2011?
Your answer should be very brief. -13.38. What is the difference between the Value added (% of GDP) of Kazakhstan in 2009 and the Value added (% of GDP) of Poland in 2011?
Keep it short and to the point. 6.55. What is the difference between the Value added (% of GDP) in Bhutan in 2010 and the Value added (% of GDP) in Cuba in 2011?
Your answer should be very brief. 24.02. What is the difference between the Value added (% of GDP) of Bhutan in 2010 and the Value added (% of GDP) of Kazakhstan in 2011?
Your response must be concise. 3.67. What is the difference between the Value added (% of GDP) of Bhutan in 2010 and the Value added (% of GDP) of Poland in 2011?
Offer a terse response. 10.81. What is the difference between the Value added (% of GDP) of Cuba in 2010 and the Value added (% of GDP) of Kazakhstan in 2011?
Keep it short and to the point. -20.36. What is the difference between the Value added (% of GDP) in Cuba in 2010 and the Value added (% of GDP) in Poland in 2011?
Keep it short and to the point. -13.21. What is the difference between the Value added (% of GDP) of Kazakhstan in 2010 and the Value added (% of GDP) of Poland in 2011?
Give a very brief answer. 9.17. What is the average Value added (% of GDP) of Bhutan per year?
Your answer should be compact. 41.82. What is the average Value added (% of GDP) in Cuba per year?
Offer a very short reply. 20.37. What is the average Value added (% of GDP) in Kazakhstan per year?
Make the answer very short. 40.98. What is the average Value added (% of GDP) in Poland per year?
Make the answer very short. 32.85. In the year 2004, what is the difference between the Value added (% of GDP) in Bhutan and Value added (% of GDP) in Cuba?
Offer a very short reply. 17.01. In the year 2004, what is the difference between the Value added (% of GDP) in Bhutan and Value added (% of GDP) in Kazakhstan?
Ensure brevity in your answer.  0.13. In the year 2004, what is the difference between the Value added (% of GDP) of Bhutan and Value added (% of GDP) of Poland?
Give a very brief answer. 5.34. In the year 2004, what is the difference between the Value added (% of GDP) of Cuba and Value added (% of GDP) of Kazakhstan?
Your answer should be compact. -16.88. In the year 2004, what is the difference between the Value added (% of GDP) of Cuba and Value added (% of GDP) of Poland?
Your answer should be very brief. -11.66. In the year 2004, what is the difference between the Value added (% of GDP) of Kazakhstan and Value added (% of GDP) of Poland?
Give a very brief answer. 5.22. In the year 2005, what is the difference between the Value added (% of GDP) of Bhutan and Value added (% of GDP) of Cuba?
Provide a succinct answer. 17.92. In the year 2005, what is the difference between the Value added (% of GDP) of Bhutan and Value added (% of GDP) of Kazakhstan?
Ensure brevity in your answer.  -2.81. In the year 2005, what is the difference between the Value added (% of GDP) of Bhutan and Value added (% of GDP) of Poland?
Your answer should be compact. 5.21. In the year 2005, what is the difference between the Value added (% of GDP) of Cuba and Value added (% of GDP) of Kazakhstan?
Your response must be concise. -20.73. In the year 2005, what is the difference between the Value added (% of GDP) in Cuba and Value added (% of GDP) in Poland?
Give a very brief answer. -12.71. In the year 2005, what is the difference between the Value added (% of GDP) in Kazakhstan and Value added (% of GDP) in Poland?
Keep it short and to the point. 8.02. In the year 2006, what is the difference between the Value added (% of GDP) in Bhutan and Value added (% of GDP) in Cuba?
Your response must be concise. 18.76. In the year 2006, what is the difference between the Value added (% of GDP) in Bhutan and Value added (% of GDP) in Kazakhstan?
Make the answer very short. -3.12. In the year 2006, what is the difference between the Value added (% of GDP) in Bhutan and Value added (% of GDP) in Poland?
Offer a very short reply. 6.22. In the year 2006, what is the difference between the Value added (% of GDP) of Cuba and Value added (% of GDP) of Kazakhstan?
Offer a very short reply. -21.88. In the year 2006, what is the difference between the Value added (% of GDP) in Cuba and Value added (% of GDP) in Poland?
Offer a very short reply. -12.54. In the year 2006, what is the difference between the Value added (% of GDP) of Kazakhstan and Value added (% of GDP) of Poland?
Offer a very short reply. 9.34. In the year 2007, what is the difference between the Value added (% of GDP) of Bhutan and Value added (% of GDP) of Cuba?
Provide a short and direct response. 24.88. In the year 2007, what is the difference between the Value added (% of GDP) in Bhutan and Value added (% of GDP) in Kazakhstan?
Make the answer very short. 4.74. In the year 2007, what is the difference between the Value added (% of GDP) in Bhutan and Value added (% of GDP) in Poland?
Your response must be concise. 12.54. In the year 2007, what is the difference between the Value added (% of GDP) of Cuba and Value added (% of GDP) of Kazakhstan?
Provide a short and direct response. -20.15. In the year 2007, what is the difference between the Value added (% of GDP) in Cuba and Value added (% of GDP) in Poland?
Your answer should be compact. -12.34. In the year 2007, what is the difference between the Value added (% of GDP) of Kazakhstan and Value added (% of GDP) of Poland?
Offer a very short reply. 7.8. In the year 2008, what is the difference between the Value added (% of GDP) in Bhutan and Value added (% of GDP) in Cuba?
Provide a short and direct response. 23.74. In the year 2008, what is the difference between the Value added (% of GDP) of Bhutan and Value added (% of GDP) of Kazakhstan?
Keep it short and to the point. 1.17. In the year 2008, what is the difference between the Value added (% of GDP) in Bhutan and Value added (% of GDP) in Poland?
Your answer should be very brief. 11.52. In the year 2008, what is the difference between the Value added (% of GDP) in Cuba and Value added (% of GDP) in Kazakhstan?
Provide a short and direct response. -22.58. In the year 2008, what is the difference between the Value added (% of GDP) in Cuba and Value added (% of GDP) in Poland?
Your answer should be very brief. -12.22. In the year 2008, what is the difference between the Value added (% of GDP) in Kazakhstan and Value added (% of GDP) in Poland?
Ensure brevity in your answer.  10.36. In the year 2009, what is the difference between the Value added (% of GDP) in Bhutan and Value added (% of GDP) in Cuba?
Provide a short and direct response. 22.82. In the year 2009, what is the difference between the Value added (% of GDP) in Bhutan and Value added (% of GDP) in Kazakhstan?
Offer a terse response. 2.88. In the year 2009, what is the difference between the Value added (% of GDP) of Bhutan and Value added (% of GDP) of Poland?
Give a very brief answer. 10.03. In the year 2009, what is the difference between the Value added (% of GDP) in Cuba and Value added (% of GDP) in Kazakhstan?
Provide a succinct answer. -19.93. In the year 2009, what is the difference between the Value added (% of GDP) in Cuba and Value added (% of GDP) in Poland?
Provide a succinct answer. -12.78. In the year 2009, what is the difference between the Value added (% of GDP) of Kazakhstan and Value added (% of GDP) of Poland?
Provide a short and direct response. 7.15. In the year 2010, what is the difference between the Value added (% of GDP) in Bhutan and Value added (% of GDP) in Cuba?
Make the answer very short. 24.03. In the year 2010, what is the difference between the Value added (% of GDP) in Bhutan and Value added (% of GDP) in Kazakhstan?
Keep it short and to the point. 1.65. In the year 2010, what is the difference between the Value added (% of GDP) in Bhutan and Value added (% of GDP) in Poland?
Offer a very short reply. 11.6. In the year 2010, what is the difference between the Value added (% of GDP) of Cuba and Value added (% of GDP) of Kazakhstan?
Your answer should be compact. -22.38. In the year 2010, what is the difference between the Value added (% of GDP) in Cuba and Value added (% of GDP) in Poland?
Give a very brief answer. -12.43. In the year 2010, what is the difference between the Value added (% of GDP) of Kazakhstan and Value added (% of GDP) of Poland?
Ensure brevity in your answer.  9.95. In the year 2011, what is the difference between the Value added (% of GDP) of Bhutan and Value added (% of GDP) of Cuba?
Make the answer very short. 22.44. In the year 2011, what is the difference between the Value added (% of GDP) in Bhutan and Value added (% of GDP) in Kazakhstan?
Provide a succinct answer. 2.09. In the year 2011, what is the difference between the Value added (% of GDP) of Bhutan and Value added (% of GDP) of Poland?
Provide a succinct answer. 9.24. In the year 2011, what is the difference between the Value added (% of GDP) in Cuba and Value added (% of GDP) in Kazakhstan?
Give a very brief answer. -20.35. In the year 2011, what is the difference between the Value added (% of GDP) of Cuba and Value added (% of GDP) of Poland?
Keep it short and to the point. -13.21. In the year 2011, what is the difference between the Value added (% of GDP) of Kazakhstan and Value added (% of GDP) of Poland?
Offer a terse response. 7.15. What is the ratio of the Value added (% of GDP) of Bhutan in 2004 to that in 2005?
Keep it short and to the point. 1.01. What is the ratio of the Value added (% of GDP) of Cuba in 2004 to that in 2005?
Your response must be concise. 1.07. What is the ratio of the Value added (% of GDP) of Kazakhstan in 2004 to that in 2005?
Provide a succinct answer. 0.94. What is the ratio of the Value added (% of GDP) in Poland in 2004 to that in 2005?
Make the answer very short. 1.01. What is the ratio of the Value added (% of GDP) in Bhutan in 2004 to that in 2006?
Your response must be concise. 0.97. What is the ratio of the Value added (% of GDP) of Cuba in 2004 to that in 2006?
Offer a terse response. 1.03. What is the ratio of the Value added (% of GDP) in Kazakhstan in 2004 to that in 2006?
Ensure brevity in your answer.  0.89. What is the ratio of the Value added (% of GDP) in Poland in 2004 to that in 2006?
Provide a short and direct response. 0.99. What is the ratio of the Value added (% of GDP) in Bhutan in 2004 to that in 2007?
Offer a terse response. 0.83. What is the ratio of the Value added (% of GDP) in Cuba in 2004 to that in 2007?
Provide a succinct answer. 1.01. What is the ratio of the Value added (% of GDP) in Kazakhstan in 2004 to that in 2007?
Provide a short and direct response. 0.93. What is the ratio of the Value added (% of GDP) in Poland in 2004 to that in 2007?
Your response must be concise. 0.99. What is the ratio of the Value added (% of GDP) of Bhutan in 2004 to that in 2008?
Offer a terse response. 0.85. What is the ratio of the Value added (% of GDP) in Kazakhstan in 2004 to that in 2008?
Your answer should be very brief. 0.87. What is the ratio of the Value added (% of GDP) of Poland in 2004 to that in 2008?
Your answer should be compact. 0.98. What is the ratio of the Value added (% of GDP) in Bhutan in 2004 to that in 2009?
Give a very brief answer. 0.87. What is the ratio of the Value added (% of GDP) in Cuba in 2004 to that in 2009?
Your answer should be compact. 1.02. What is the ratio of the Value added (% of GDP) in Kazakhstan in 2004 to that in 2009?
Ensure brevity in your answer.  0.93. What is the ratio of the Value added (% of GDP) in Poland in 2004 to that in 2009?
Offer a very short reply. 0.98. What is the ratio of the Value added (% of GDP) of Bhutan in 2004 to that in 2010?
Provide a succinct answer. 0.85. What is the ratio of the Value added (% of GDP) of Cuba in 2004 to that in 2010?
Make the answer very short. 1.01. What is the ratio of the Value added (% of GDP) in Kazakhstan in 2004 to that in 2010?
Your answer should be very brief. 0.88. What is the ratio of the Value added (% of GDP) in Poland in 2004 to that in 2010?
Ensure brevity in your answer.  0.98. What is the ratio of the Value added (% of GDP) in Bhutan in 2004 to that in 2011?
Your answer should be very brief. 0.88. What is the ratio of the Value added (% of GDP) in Cuba in 2004 to that in 2011?
Your response must be concise. 1.01. What is the ratio of the Value added (% of GDP) of Kazakhstan in 2004 to that in 2011?
Offer a terse response. 0.92. What is the ratio of the Value added (% of GDP) of Poland in 2004 to that in 2011?
Your response must be concise. 0.96. What is the ratio of the Value added (% of GDP) of Bhutan in 2005 to that in 2006?
Give a very brief answer. 0.96. What is the ratio of the Value added (% of GDP) of Cuba in 2005 to that in 2006?
Keep it short and to the point. 0.96. What is the ratio of the Value added (% of GDP) of Kazakhstan in 2005 to that in 2006?
Provide a short and direct response. 0.95. What is the ratio of the Value added (% of GDP) in Poland in 2005 to that in 2006?
Offer a terse response. 0.98. What is the ratio of the Value added (% of GDP) of Bhutan in 2005 to that in 2007?
Your answer should be compact. 0.82. What is the ratio of the Value added (% of GDP) of Cuba in 2005 to that in 2007?
Offer a very short reply. 0.95. What is the ratio of the Value added (% of GDP) in Kazakhstan in 2005 to that in 2007?
Keep it short and to the point. 0.99. What is the ratio of the Value added (% of GDP) in Bhutan in 2005 to that in 2008?
Keep it short and to the point. 0.84. What is the ratio of the Value added (% of GDP) of Cuba in 2005 to that in 2008?
Your response must be concise. 0.94. What is the ratio of the Value added (% of GDP) of Kazakhstan in 2005 to that in 2008?
Offer a terse response. 0.93. What is the ratio of the Value added (% of GDP) in Poland in 2005 to that in 2008?
Provide a short and direct response. 0.97. What is the ratio of the Value added (% of GDP) in Bhutan in 2005 to that in 2009?
Offer a very short reply. 0.86. What is the ratio of the Value added (% of GDP) of Cuba in 2005 to that in 2009?
Your response must be concise. 0.95. What is the ratio of the Value added (% of GDP) of Kazakhstan in 2005 to that in 2009?
Your answer should be compact. 1. What is the ratio of the Value added (% of GDP) in Poland in 2005 to that in 2009?
Provide a short and direct response. 0.97. What is the ratio of the Value added (% of GDP) of Bhutan in 2005 to that in 2010?
Offer a very short reply. 0.84. What is the ratio of the Value added (% of GDP) of Cuba in 2005 to that in 2010?
Make the answer very short. 0.94. What is the ratio of the Value added (% of GDP) of Kazakhstan in 2005 to that in 2010?
Give a very brief answer. 0.93. What is the ratio of the Value added (% of GDP) of Poland in 2005 to that in 2010?
Provide a succinct answer. 0.97. What is the ratio of the Value added (% of GDP) of Bhutan in 2005 to that in 2011?
Make the answer very short. 0.87. What is the ratio of the Value added (% of GDP) of Cuba in 2005 to that in 2011?
Your answer should be very brief. 0.94. What is the ratio of the Value added (% of GDP) of Kazakhstan in 2005 to that in 2011?
Offer a terse response. 0.98. What is the ratio of the Value added (% of GDP) in Poland in 2005 to that in 2011?
Offer a terse response. 0.95. What is the ratio of the Value added (% of GDP) of Bhutan in 2006 to that in 2007?
Give a very brief answer. 0.86. What is the ratio of the Value added (% of GDP) in Cuba in 2006 to that in 2007?
Provide a short and direct response. 0.99. What is the ratio of the Value added (% of GDP) of Kazakhstan in 2006 to that in 2007?
Your response must be concise. 1.04. What is the ratio of the Value added (% of GDP) of Bhutan in 2006 to that in 2008?
Ensure brevity in your answer.  0.88. What is the ratio of the Value added (% of GDP) of Cuba in 2006 to that in 2008?
Your response must be concise. 0.98. What is the ratio of the Value added (% of GDP) of Kazakhstan in 2006 to that in 2008?
Make the answer very short. 0.97. What is the ratio of the Value added (% of GDP) of Poland in 2006 to that in 2008?
Provide a short and direct response. 0.99. What is the ratio of the Value added (% of GDP) in Bhutan in 2006 to that in 2009?
Offer a very short reply. 0.9. What is the ratio of the Value added (% of GDP) in Cuba in 2006 to that in 2009?
Make the answer very short. 0.99. What is the ratio of the Value added (% of GDP) of Kazakhstan in 2006 to that in 2009?
Keep it short and to the point. 1.05. What is the ratio of the Value added (% of GDP) in Bhutan in 2006 to that in 2010?
Provide a succinct answer. 0.88. What is the ratio of the Value added (% of GDP) in Cuba in 2006 to that in 2010?
Your answer should be compact. 0.99. What is the ratio of the Value added (% of GDP) of Kazakhstan in 2006 to that in 2010?
Keep it short and to the point. 0.98. What is the ratio of the Value added (% of GDP) of Poland in 2006 to that in 2010?
Your answer should be very brief. 0.99. What is the ratio of the Value added (% of GDP) in Bhutan in 2006 to that in 2011?
Offer a terse response. 0.91. What is the ratio of the Value added (% of GDP) of Cuba in 2006 to that in 2011?
Offer a very short reply. 0.99. What is the ratio of the Value added (% of GDP) of Kazakhstan in 2006 to that in 2011?
Give a very brief answer. 1.03. What is the ratio of the Value added (% of GDP) in Poland in 2006 to that in 2011?
Provide a short and direct response. 0.97. What is the ratio of the Value added (% of GDP) of Bhutan in 2007 to that in 2008?
Keep it short and to the point. 1.02. What is the ratio of the Value added (% of GDP) in Kazakhstan in 2007 to that in 2008?
Keep it short and to the point. 0.94. What is the ratio of the Value added (% of GDP) of Poland in 2007 to that in 2008?
Your response must be concise. 1. What is the ratio of the Value added (% of GDP) of Bhutan in 2007 to that in 2009?
Give a very brief answer. 1.05. What is the ratio of the Value added (% of GDP) in Kazakhstan in 2007 to that in 2009?
Offer a terse response. 1.01. What is the ratio of the Value added (% of GDP) of Poland in 2007 to that in 2009?
Give a very brief answer. 0.99. What is the ratio of the Value added (% of GDP) of Bhutan in 2007 to that in 2010?
Ensure brevity in your answer.  1.02. What is the ratio of the Value added (% of GDP) in Cuba in 2007 to that in 2010?
Ensure brevity in your answer.  1. What is the ratio of the Value added (% of GDP) in Kazakhstan in 2007 to that in 2010?
Make the answer very short. 0.95. What is the ratio of the Value added (% of GDP) in Poland in 2007 to that in 2010?
Offer a very short reply. 1. What is the ratio of the Value added (% of GDP) of Bhutan in 2007 to that in 2011?
Offer a very short reply. 1.06. What is the ratio of the Value added (% of GDP) of Kazakhstan in 2007 to that in 2011?
Offer a very short reply. 0.99. What is the ratio of the Value added (% of GDP) of Poland in 2007 to that in 2011?
Your answer should be compact. 0.97. What is the ratio of the Value added (% of GDP) of Bhutan in 2008 to that in 2009?
Provide a short and direct response. 1.03. What is the ratio of the Value added (% of GDP) of Cuba in 2008 to that in 2009?
Offer a terse response. 1.02. What is the ratio of the Value added (% of GDP) in Kazakhstan in 2008 to that in 2009?
Ensure brevity in your answer.  1.07. What is the ratio of the Value added (% of GDP) of Bhutan in 2008 to that in 2010?
Provide a short and direct response. 1. What is the ratio of the Value added (% of GDP) of Cuba in 2008 to that in 2010?
Your answer should be very brief. 1.01. What is the ratio of the Value added (% of GDP) of Kazakhstan in 2008 to that in 2010?
Your answer should be compact. 1.01. What is the ratio of the Value added (% of GDP) of Bhutan in 2008 to that in 2011?
Offer a terse response. 1.03. What is the ratio of the Value added (% of GDP) in Cuba in 2008 to that in 2011?
Keep it short and to the point. 1.01. What is the ratio of the Value added (% of GDP) in Kazakhstan in 2008 to that in 2011?
Make the answer very short. 1.06. What is the ratio of the Value added (% of GDP) in Poland in 2008 to that in 2011?
Provide a short and direct response. 0.98. What is the ratio of the Value added (% of GDP) in Bhutan in 2009 to that in 2010?
Give a very brief answer. 0.97. What is the ratio of the Value added (% of GDP) in Kazakhstan in 2009 to that in 2010?
Give a very brief answer. 0.94. What is the ratio of the Value added (% of GDP) in Poland in 2009 to that in 2010?
Provide a short and direct response. 1.01. What is the ratio of the Value added (% of GDP) in Kazakhstan in 2009 to that in 2011?
Your response must be concise. 0.99. What is the ratio of the Value added (% of GDP) of Poland in 2009 to that in 2011?
Offer a terse response. 0.98. What is the ratio of the Value added (% of GDP) in Bhutan in 2010 to that in 2011?
Keep it short and to the point. 1.04. What is the ratio of the Value added (% of GDP) in Kazakhstan in 2010 to that in 2011?
Provide a short and direct response. 1.05. What is the ratio of the Value added (% of GDP) in Poland in 2010 to that in 2011?
Give a very brief answer. 0.98. What is the difference between the highest and the second highest Value added (% of GDP) in Bhutan?
Your answer should be very brief. 0.83. What is the difference between the highest and the second highest Value added (% of GDP) in Cuba?
Provide a short and direct response. 0.03. What is the difference between the highest and the second highest Value added (% of GDP) in Kazakhstan?
Your answer should be very brief. 0.39. What is the difference between the highest and the second highest Value added (% of GDP) in Poland?
Make the answer very short. 0.6. What is the difference between the highest and the lowest Value added (% of GDP) in Bhutan?
Offer a terse response. 8.09. What is the difference between the highest and the lowest Value added (% of GDP) in Cuba?
Offer a terse response. 1.36. What is the difference between the highest and the lowest Value added (% of GDP) of Kazakhstan?
Your response must be concise. 5.67. What is the difference between the highest and the lowest Value added (% of GDP) of Poland?
Ensure brevity in your answer.  1.65. 